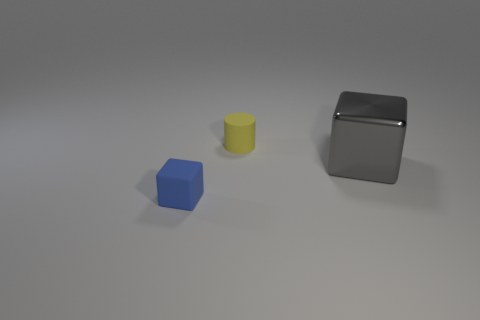Add 3 small metallic spheres. How many objects exist? 6 Subtract all cubes. How many objects are left? 1 Subtract 1 cylinders. How many cylinders are left? 0 Subtract all purple cubes. Subtract all purple cylinders. How many cubes are left? 2 Subtract all yellow spheres. How many green cylinders are left? 0 Subtract all big brown rubber cubes. Subtract all cubes. How many objects are left? 1 Add 3 yellow things. How many yellow things are left? 4 Add 2 green things. How many green things exist? 2 Subtract all blue cubes. How many cubes are left? 1 Subtract 0 green blocks. How many objects are left? 3 